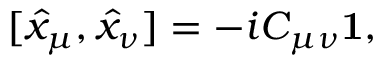<formula> <loc_0><loc_0><loc_500><loc_500>[ \hat { x } _ { \mu } , \hat { x } _ { \nu } ] = - i C _ { \mu \nu } { 1 } ,</formula> 